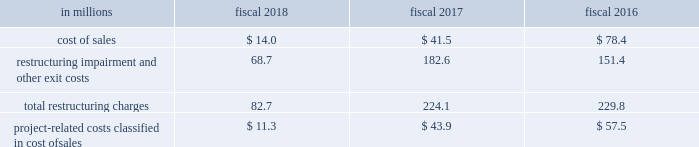Reduced administrative expense .
In connection with this project , we eliminated 749 positions .
We incurred $ 54.7 million of net expenses , most of which was cash .
We recorded $ 0.4 million of restructuring charges relating to this action in fiscal 2018 , restructuring charges were reduced by $ 0.4 million in fiscal 2017 , and we incurred $ 54.7 million of restructuring charges in fiscal 2016 .
This action was completed in fiscal 2018 .
In fiscal 2015 , we announced project century ( century ) which initially involved a review of our north american manufacturing and distribution network to streamline operations and identify potential capacity reductions .
In fiscal 2016 , we broadened the scope of century to identify opportunities to streamline our supply chain outside of north america .
As part of century , in the second quarter of fiscal 2016 , we approved a restructuring plan to close manufacturing facilities in our europe & australia segment supply chain located in berwick , united kingdom and east tamaki , new zealand .
These actions affected 287 positions and we incurred $ 31.8 million of net expenses related to these actions , of which $ 12 million was cash .
We recorded $ 1.8 million of restructuring charges relating to these actions in fiscal 2017 and $ 30.0 million in fiscal 2016 .
These actions were completed in fiscal 2017 .
As part of century , in the first quarter of fiscal 2016 , we approved a restructuring plan to close our west chicago , illinois cereal and dry dinner manufacturing plant in our north america retail segment supply chain .
This action affected 484 positions , and we incurred $ 109.3 million of net expenses relating to this action , of which $ 21 million was cash .
We recorded $ 6.9 million of restructuring charges relating to this action in fiscal 2018 , $ 23.2 million in fiscal 2017 and $ 79.2 million in fiscal 2016 .
This action was completed in fiscal 2018 .
As part of century , in the first quarter of fiscal 2016 , we approved a restructuring plan to close our joplin , missouri snacks plant in our north america retail segment supply chain .
This action affected 125 positions , and we incurred $ 8.0 million of net expenses relating to this action , of which less than $ 1 million was cash .
We recorded $ 1.4 million of restructuring charges relating to this action in fiscal 2018 , $ 0.3 million in fiscal 2017 , and $ 6.3 million in fiscal 2016 .
This action was completed in fiscal 2018 .
We paid cash related to restructuring initiatives of $ 53.6 million in fiscal 2018 , $ 107.8 million in fiscal 2017 , and $ 122.6 million in fiscal 2016 .
In addition to restructuring charges , we expect to incur approximately $ 130 million of project-related costs , which will be recorded in cost of sales , all of which will be cash .
We recorded project-related costs in cost of sales of $ 11.3 million in fiscal 2018 , $ 43.9 million in fiscal 2017 , and $ 57.5 million in fiscal 2016 .
We paid cash for project-related costs of $ 10.9 million in fiscal 2018 , $ 46.9 million in fiscal 2017 , and $ 54.5 million in fiscal 2016 .
We expect these activities to be completed in fiscal 2019 .
Restructuring charges and project-related costs are classified in our consolidated statements of earnings as follows: .

What are the total restructuring charges for the last three years? 
Computations: ((82.7 + 224.1) + 229.8)
Answer: 536.6. 